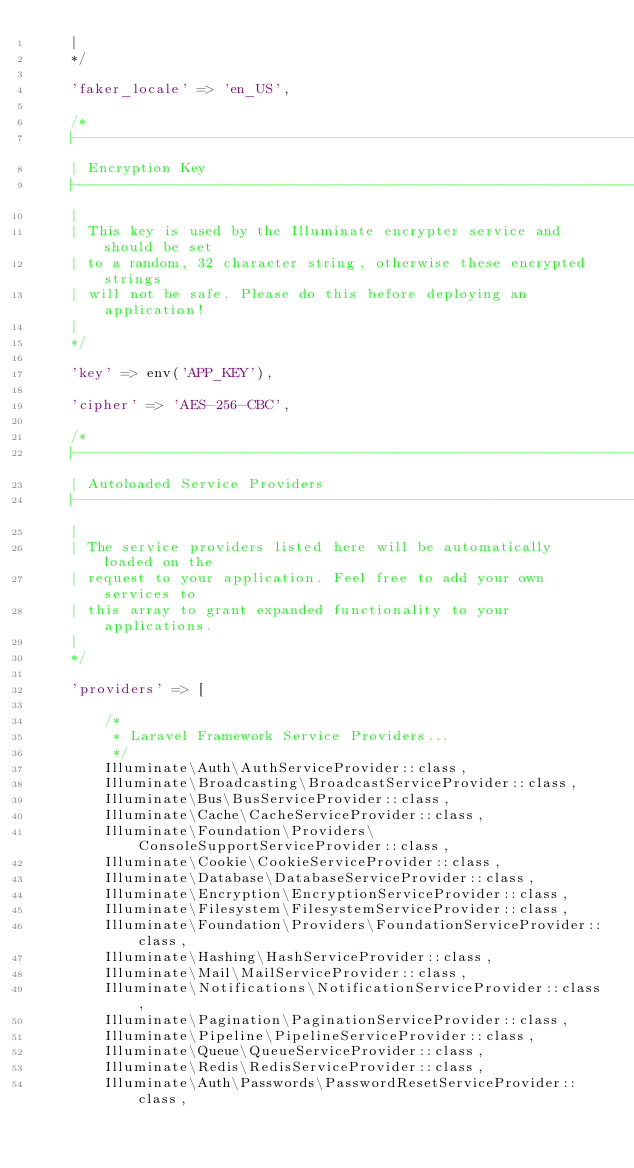<code> <loc_0><loc_0><loc_500><loc_500><_PHP_>    |
    */

    'faker_locale' => 'en_US',

    /*
    |--------------------------------------------------------------------------
    | Encryption Key
    |--------------------------------------------------------------------------
    |
    | This key is used by the Illuminate encrypter service and should be set
    | to a random, 32 character string, otherwise these encrypted strings
    | will not be safe. Please do this before deploying an application!
    |
    */

    'key' => env('APP_KEY'),

    'cipher' => 'AES-256-CBC',

    /*
    |--------------------------------------------------------------------------
    | Autoloaded Service Providers
    |--------------------------------------------------------------------------
    |
    | The service providers listed here will be automatically loaded on the
    | request to your application. Feel free to add your own services to
    | this array to grant expanded functionality to your applications.
    |
    */

    'providers' => [

        /*
         * Laravel Framework Service Providers...
         */
        Illuminate\Auth\AuthServiceProvider::class,
        Illuminate\Broadcasting\BroadcastServiceProvider::class,
        Illuminate\Bus\BusServiceProvider::class,
        Illuminate\Cache\CacheServiceProvider::class,
        Illuminate\Foundation\Providers\ConsoleSupportServiceProvider::class,
        Illuminate\Cookie\CookieServiceProvider::class,
        Illuminate\Database\DatabaseServiceProvider::class,
        Illuminate\Encryption\EncryptionServiceProvider::class,
        Illuminate\Filesystem\FilesystemServiceProvider::class,
        Illuminate\Foundation\Providers\FoundationServiceProvider::class,
        Illuminate\Hashing\HashServiceProvider::class,
        Illuminate\Mail\MailServiceProvider::class,
        Illuminate\Notifications\NotificationServiceProvider::class,
        Illuminate\Pagination\PaginationServiceProvider::class,
        Illuminate\Pipeline\PipelineServiceProvider::class,
        Illuminate\Queue\QueueServiceProvider::class,
        Illuminate\Redis\RedisServiceProvider::class,
        Illuminate\Auth\Passwords\PasswordResetServiceProvider::class,</code> 